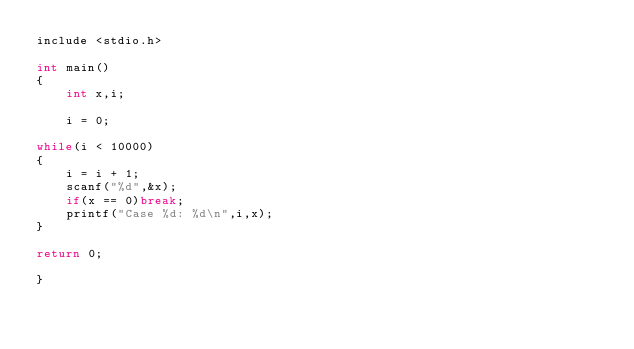Convert code to text. <code><loc_0><loc_0><loc_500><loc_500><_C_>include <stdio.h>

int main()
{
    int x,i;
 
    i = 0;
 
while(i < 10000)
{
    i = i + 1;
    scanf("%d",&x);
    if(x == 0)break;
    printf("Case %d: %d\n",i,x);
}
 
return 0;
 
}</code> 